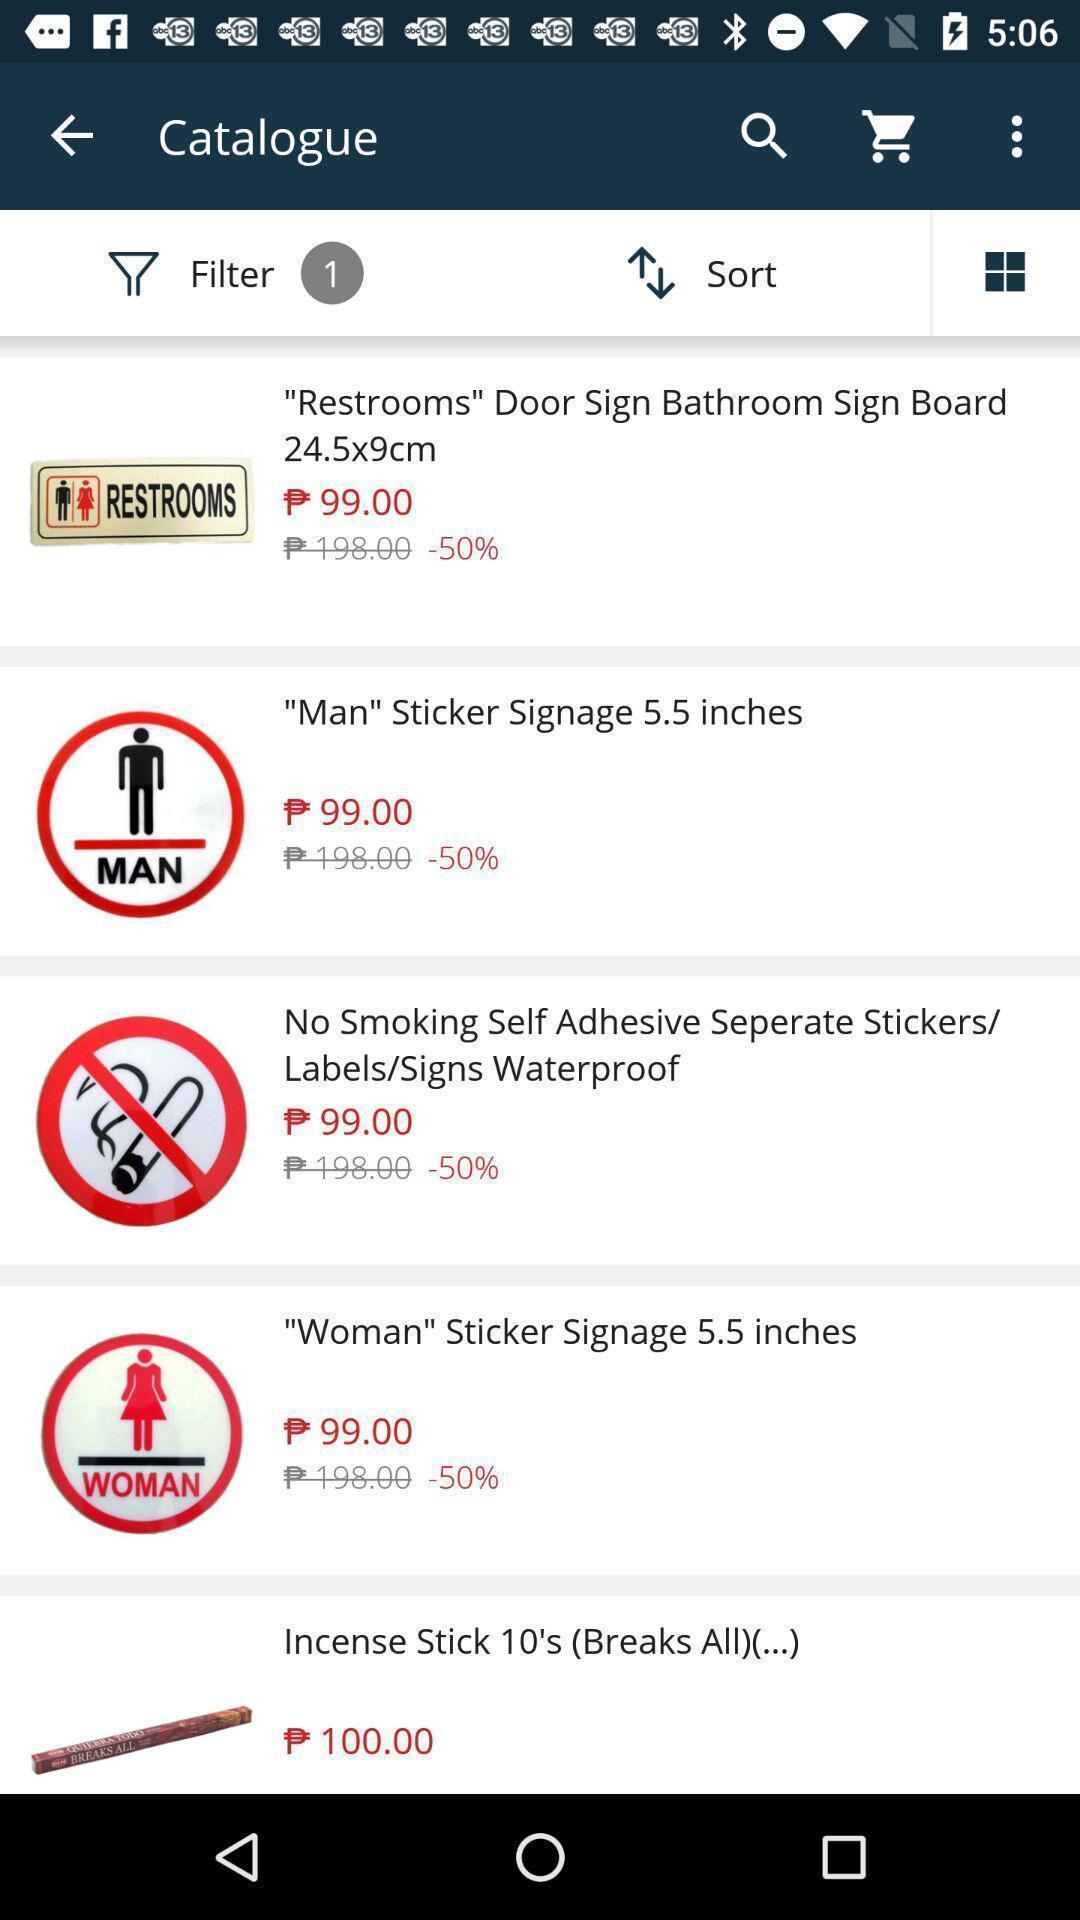Provide a textual representation of this image. Shopping app displayed catalogue of different items. 